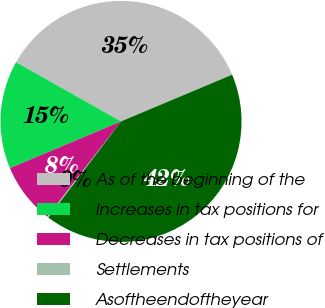<chart> <loc_0><loc_0><loc_500><loc_500><pie_chart><fcel>As of the beginning of the<fcel>Increases in tax positions for<fcel>Decreases in tax positions of<fcel>Settlements<fcel>Asoftheendoftheyear<nl><fcel>35.49%<fcel>14.51%<fcel>8.19%<fcel>0.17%<fcel>41.64%<nl></chart> 